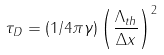<formula> <loc_0><loc_0><loc_500><loc_500>\tau _ { D } = ( 1 / 4 \pi \gamma ) \left ( \frac { \Lambda _ { t h } } { \Delta x } \right ) ^ { 2 }</formula> 